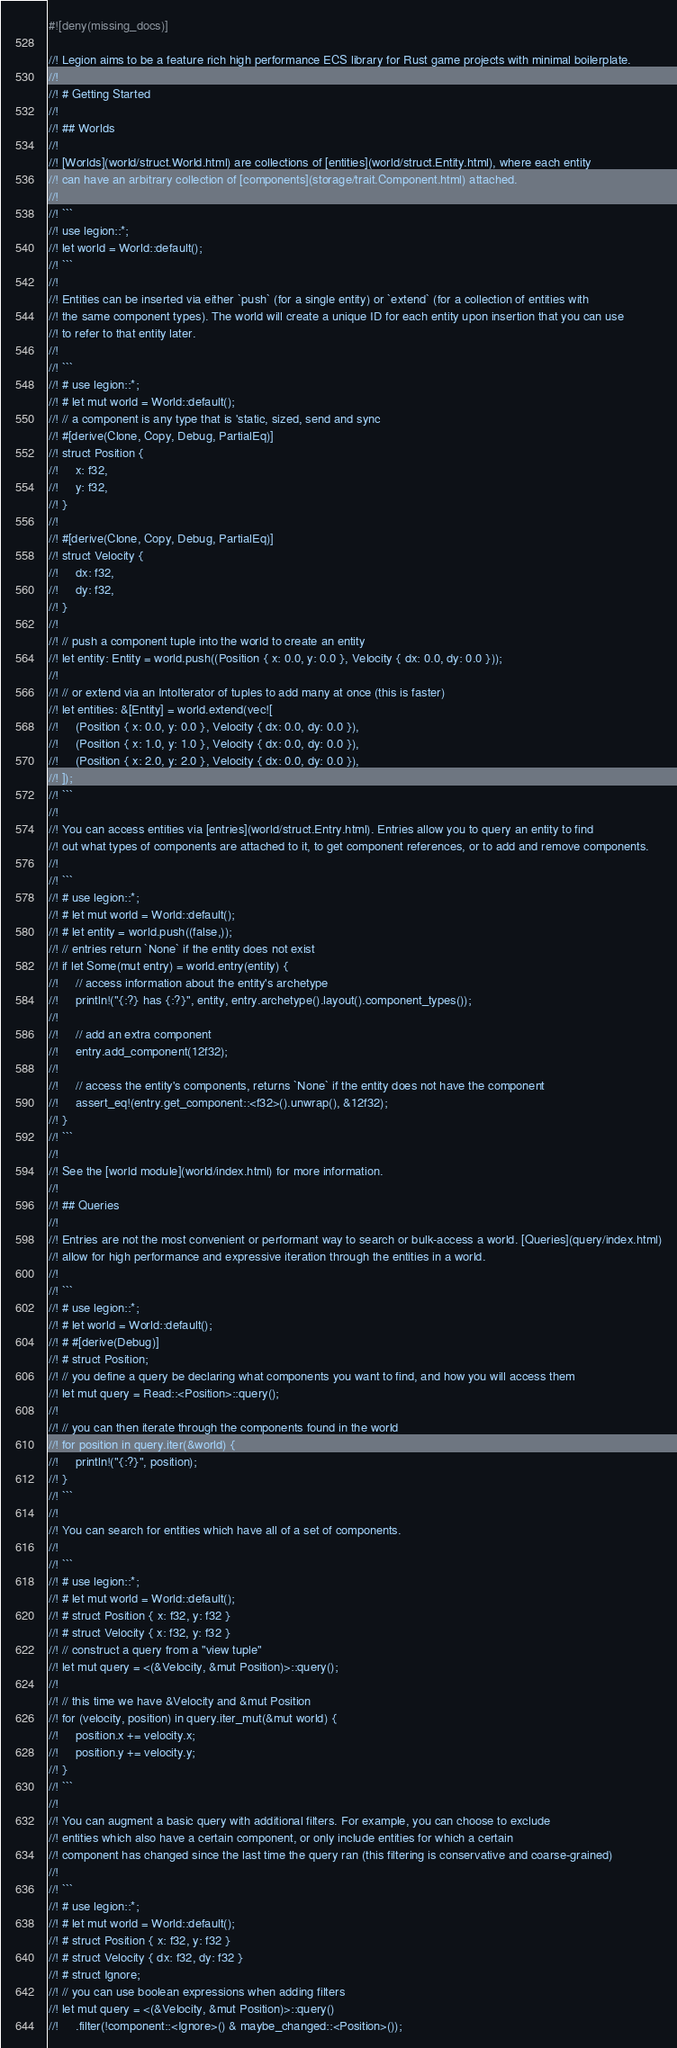<code> <loc_0><loc_0><loc_500><loc_500><_Rust_>#![deny(missing_docs)]

//! Legion aims to be a feature rich high performance ECS library for Rust game projects with minimal boilerplate.
//!
//! # Getting Started
//!
//! ## Worlds
//!
//! [Worlds](world/struct.World.html) are collections of [entities](world/struct.Entity.html), where each entity
//! can have an arbitrary collection of [components](storage/trait.Component.html) attached.
//!
//! ```
//! use legion::*;
//! let world = World::default();
//! ```
//!
//! Entities can be inserted via either `push` (for a single entity) or `extend` (for a collection of entities with
//! the same component types). The world will create a unique ID for each entity upon insertion that you can use
//! to refer to that entity later.
//!
//! ```
//! # use legion::*;
//! # let mut world = World::default();
//! // a component is any type that is 'static, sized, send and sync
//! #[derive(Clone, Copy, Debug, PartialEq)]
//! struct Position {
//!     x: f32,
//!     y: f32,
//! }
//!
//! #[derive(Clone, Copy, Debug, PartialEq)]
//! struct Velocity {
//!     dx: f32,
//!     dy: f32,
//! }
//!
//! // push a component tuple into the world to create an entity
//! let entity: Entity = world.push((Position { x: 0.0, y: 0.0 }, Velocity { dx: 0.0, dy: 0.0 }));
//!
//! // or extend via an IntoIterator of tuples to add many at once (this is faster)
//! let entities: &[Entity] = world.extend(vec![
//!     (Position { x: 0.0, y: 0.0 }, Velocity { dx: 0.0, dy: 0.0 }),
//!     (Position { x: 1.0, y: 1.0 }, Velocity { dx: 0.0, dy: 0.0 }),
//!     (Position { x: 2.0, y: 2.0 }, Velocity { dx: 0.0, dy: 0.0 }),
//! ]);
//! ```
//!
//! You can access entities via [entries](world/struct.Entry.html). Entries allow you to query an entity to find
//! out what types of components are attached to it, to get component references, or to add and remove components.
//!
//! ```
//! # use legion::*;
//! # let mut world = World::default();
//! # let entity = world.push((false,));
//! // entries return `None` if the entity does not exist
//! if let Some(mut entry) = world.entry(entity) {
//!     // access information about the entity's archetype
//!     println!("{:?} has {:?}", entity, entry.archetype().layout().component_types());
//!
//!     // add an extra component
//!     entry.add_component(12f32);
//!
//!     // access the entity's components, returns `None` if the entity does not have the component
//!     assert_eq!(entry.get_component::<f32>().unwrap(), &12f32);
//! }
//! ```
//!
//! See the [world module](world/index.html) for more information.
//!
//! ## Queries
//!
//! Entries are not the most convenient or performant way to search or bulk-access a world. [Queries](query/index.html)
//! allow for high performance and expressive iteration through the entities in a world.
//!
//! ```
//! # use legion::*;
//! # let world = World::default();
//! # #[derive(Debug)]
//! # struct Position;
//! // you define a query be declaring what components you want to find, and how you will access them
//! let mut query = Read::<Position>::query();
//!
//! // you can then iterate through the components found in the world
//! for position in query.iter(&world) {
//!     println!("{:?}", position);
//! }
//! ```
//!
//! You can search for entities which have all of a set of components.
//!
//! ```
//! # use legion::*;
//! # let mut world = World::default();
//! # struct Position { x: f32, y: f32 }
//! # struct Velocity { x: f32, y: f32 }
//! // construct a query from a "view tuple"
//! let mut query = <(&Velocity, &mut Position)>::query();
//!
//! // this time we have &Velocity and &mut Position
//! for (velocity, position) in query.iter_mut(&mut world) {
//!     position.x += velocity.x;
//!     position.y += velocity.y;
//! }
//! ```
//!
//! You can augment a basic query with additional filters. For example, you can choose to exclude
//! entities which also have a certain component, or only include entities for which a certain
//! component has changed since the last time the query ran (this filtering is conservative and coarse-grained)
//!
//! ```
//! # use legion::*;
//! # let mut world = World::default();
//! # struct Position { x: f32, y: f32 }
//! # struct Velocity { dx: f32, dy: f32 }
//! # struct Ignore;
//! // you can use boolean expressions when adding filters
//! let mut query = <(&Velocity, &mut Position)>::query()
//!     .filter(!component::<Ignore>() & maybe_changed::<Position>());</code> 